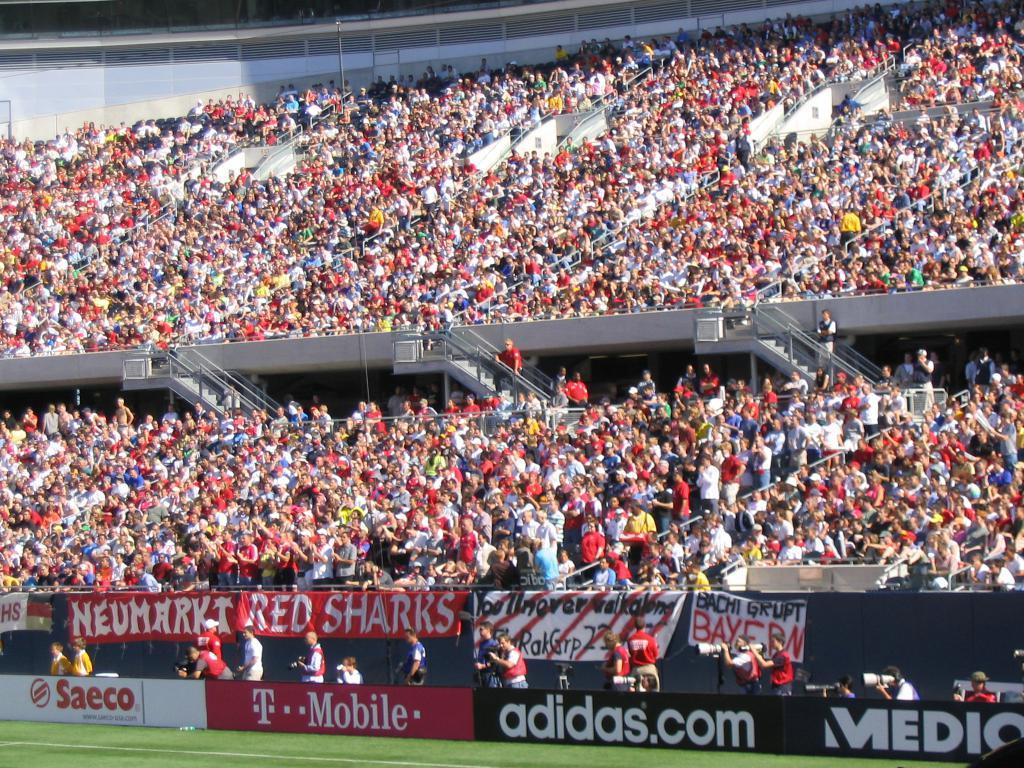In one or two sentences, can you explain what this image depicts? In this picture we can see the ground and in the background we can see an advertisement board, banners, people, staircases and some objects. 